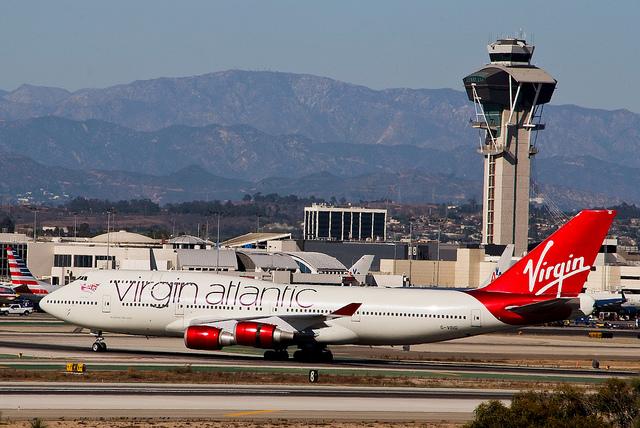What are the words on the plane?
Give a very brief answer. Virgin atlantic. Where is the plane?
Be succinct. Airport. Is the plane taking off?
Give a very brief answer. Yes. Where is the plan going?
Write a very short answer. Into sky. Is this a virgin airplane?
Concise answer only. Yes. 